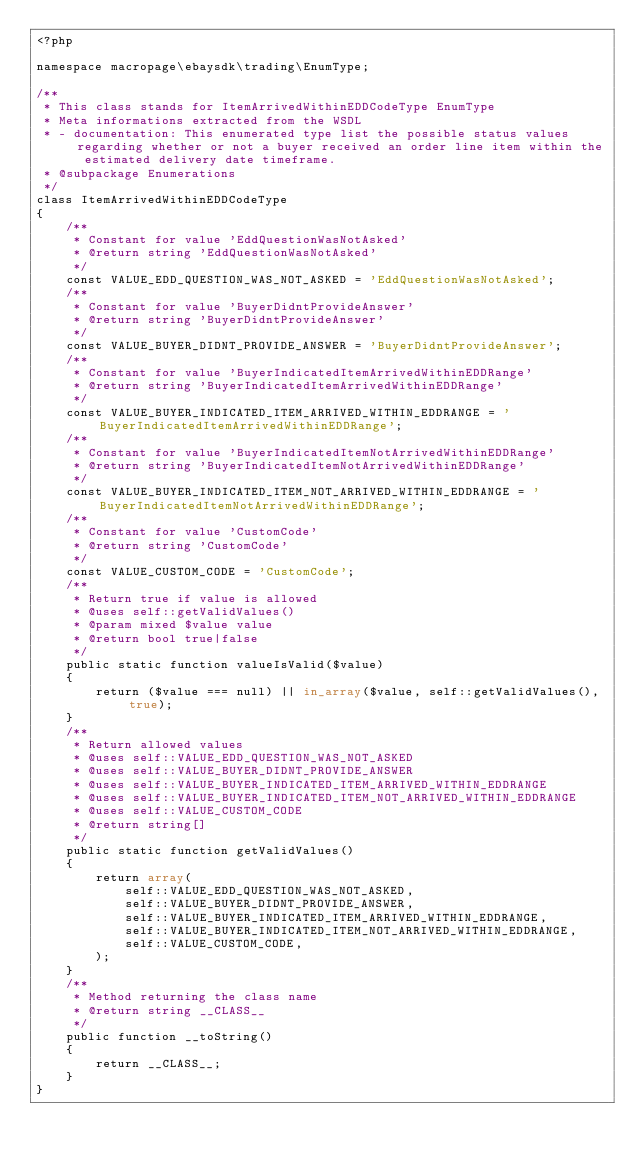<code> <loc_0><loc_0><loc_500><loc_500><_PHP_><?php

namespace macropage\ebaysdk\trading\EnumType;

/**
 * This class stands for ItemArrivedWithinEDDCodeType EnumType
 * Meta informations extracted from the WSDL
 * - documentation: This enumerated type list the possible status values regarding whether or not a buyer received an order line item within the estimated delivery date timeframe.
 * @subpackage Enumerations
 */
class ItemArrivedWithinEDDCodeType
{
    /**
     * Constant for value 'EddQuestionWasNotAsked'
     * @return string 'EddQuestionWasNotAsked'
     */
    const VALUE_EDD_QUESTION_WAS_NOT_ASKED = 'EddQuestionWasNotAsked';
    /**
     * Constant for value 'BuyerDidntProvideAnswer'
     * @return string 'BuyerDidntProvideAnswer'
     */
    const VALUE_BUYER_DIDNT_PROVIDE_ANSWER = 'BuyerDidntProvideAnswer';
    /**
     * Constant for value 'BuyerIndicatedItemArrivedWithinEDDRange'
     * @return string 'BuyerIndicatedItemArrivedWithinEDDRange'
     */
    const VALUE_BUYER_INDICATED_ITEM_ARRIVED_WITHIN_EDDRANGE = 'BuyerIndicatedItemArrivedWithinEDDRange';
    /**
     * Constant for value 'BuyerIndicatedItemNotArrivedWithinEDDRange'
     * @return string 'BuyerIndicatedItemNotArrivedWithinEDDRange'
     */
    const VALUE_BUYER_INDICATED_ITEM_NOT_ARRIVED_WITHIN_EDDRANGE = 'BuyerIndicatedItemNotArrivedWithinEDDRange';
    /**
     * Constant for value 'CustomCode'
     * @return string 'CustomCode'
     */
    const VALUE_CUSTOM_CODE = 'CustomCode';
    /**
     * Return true if value is allowed
     * @uses self::getValidValues()
     * @param mixed $value value
     * @return bool true|false
     */
    public static function valueIsValid($value)
    {
        return ($value === null) || in_array($value, self::getValidValues(), true);
    }
    /**
     * Return allowed values
     * @uses self::VALUE_EDD_QUESTION_WAS_NOT_ASKED
     * @uses self::VALUE_BUYER_DIDNT_PROVIDE_ANSWER
     * @uses self::VALUE_BUYER_INDICATED_ITEM_ARRIVED_WITHIN_EDDRANGE
     * @uses self::VALUE_BUYER_INDICATED_ITEM_NOT_ARRIVED_WITHIN_EDDRANGE
     * @uses self::VALUE_CUSTOM_CODE
     * @return string[]
     */
    public static function getValidValues()
    {
        return array(
            self::VALUE_EDD_QUESTION_WAS_NOT_ASKED,
            self::VALUE_BUYER_DIDNT_PROVIDE_ANSWER,
            self::VALUE_BUYER_INDICATED_ITEM_ARRIVED_WITHIN_EDDRANGE,
            self::VALUE_BUYER_INDICATED_ITEM_NOT_ARRIVED_WITHIN_EDDRANGE,
            self::VALUE_CUSTOM_CODE,
        );
    }
    /**
     * Method returning the class name
     * @return string __CLASS__
     */
    public function __toString()
    {
        return __CLASS__;
    }
}
</code> 